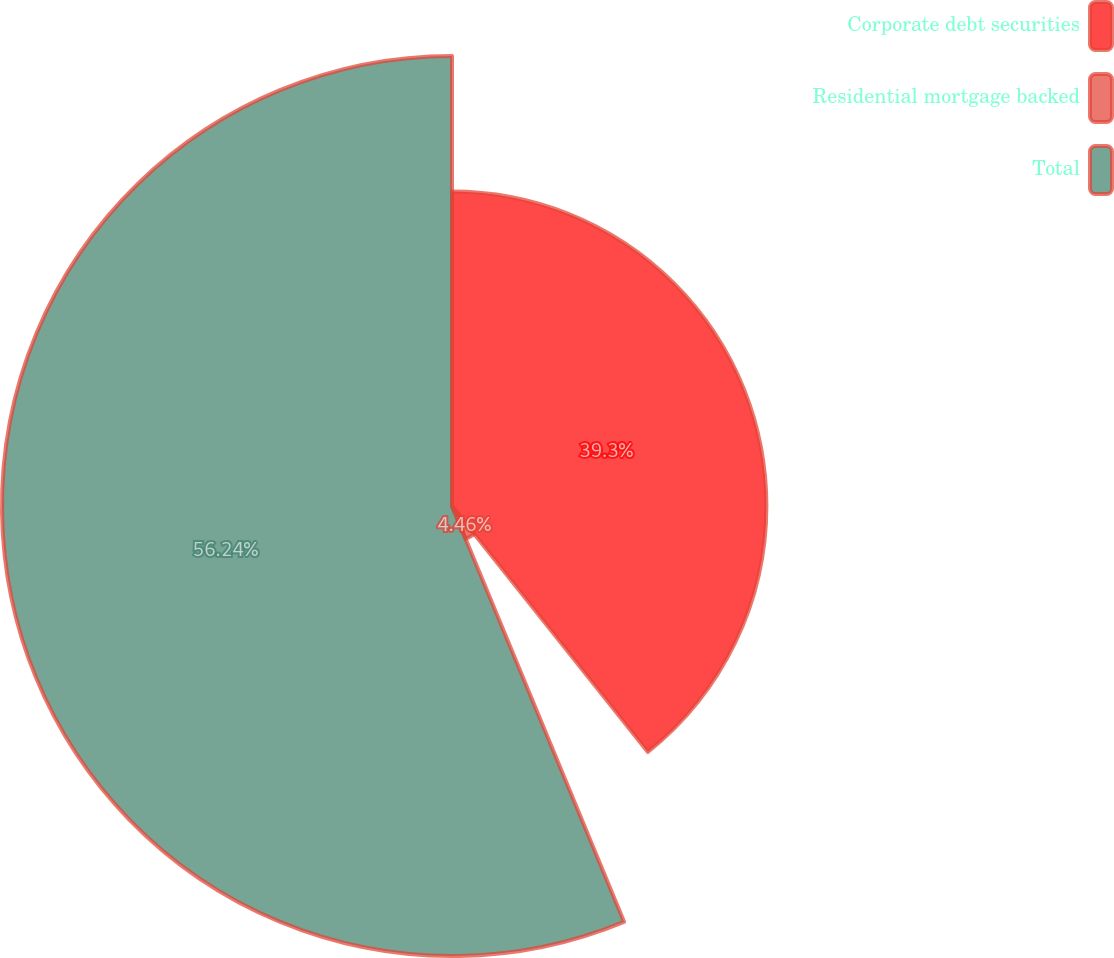Convert chart to OTSL. <chart><loc_0><loc_0><loc_500><loc_500><pie_chart><fcel>Corporate debt securities<fcel>Residential mortgage backed<fcel>Total<nl><fcel>39.3%<fcel>4.46%<fcel>56.25%<nl></chart> 